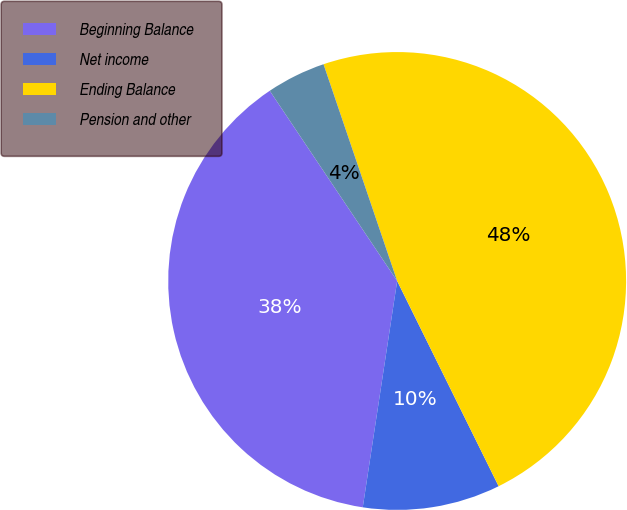Convert chart to OTSL. <chart><loc_0><loc_0><loc_500><loc_500><pie_chart><fcel>Beginning Balance<fcel>Net income<fcel>Ending Balance<fcel>Pension and other<nl><fcel>38.21%<fcel>9.71%<fcel>47.91%<fcel>4.18%<nl></chart> 